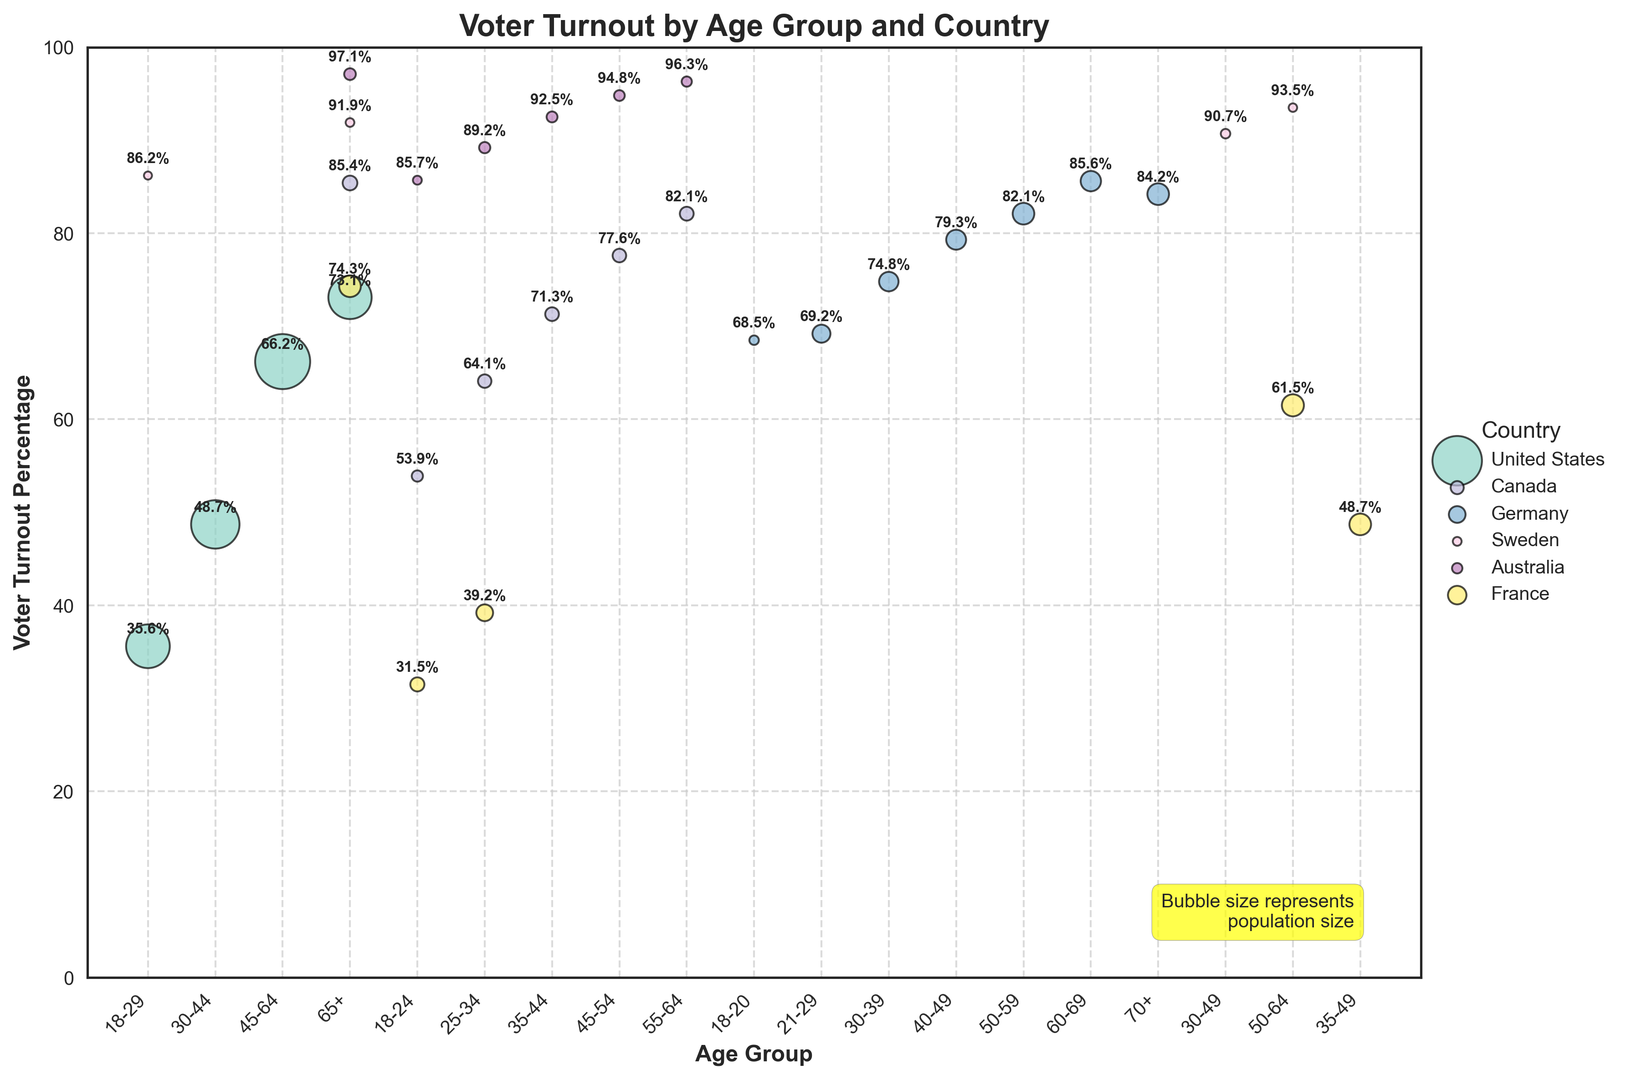What is the voter turnout percentage for the oldest age group in the United States? To find this, locate the bubble representing the United States in the age group "65+" and read off its associated percentage.
Answer: 73.1% Which country has the highest voter turnout percentage among the youngest age group? Compare the voter turnout percentages for the youngest age group across all countries, which are: United States (35.6%), Canada (53.9%), Germany (68.5%), Sweden (86.2%), Australia (85.7%), France (31.5%). The highest value is for Sweden.
Answer: Sweden Which country has the most significant difference in voter turnout percentage between the youngest and the oldest age groups? Calculate the difference between the turnout percentages for the youngest and oldest groups in each country: 
United States: 73.1 - 35.6 = 37.5, 
Canada: 85.4 - 53.9 = 31.5, 
Germany: 84.2 - 68.5 = 15.7,
Sweden: 91.9 - 86.2 = 5.7,
Australia: 97.1 - 85.7 = 11.4,
France: 74.3 - 31.5 = 42.8.
France has the most significant difference.
Answer: France Which age group shows the smallest bubble size across all countries, and what does it represent? Compare the size of the bubbles across different age groups. The smallest bubble size will be the smallest value of "Population_Size" in the dataset. The smallest size is for Sweden in the 18-29 age group, representing 1,800,000.
Answer: Sweden 18-29 Is the voter turnout percentage in the 50-64 age group higher in Canada or Germany? Compare the turnout percentages for the 50-64 age group: 
Canada: 82.1, 
Germany: 82.1.
Both are the same.
Answer: Same, 82.1 What is the average voter turnout percentage for the 18-24 age group across all countries? Add the voter turnout percentages for the 18-24 age group and divide by the number of countries: 
(35.6 + 53.9 + 68.5 + 86.2 + 85.7 + 31.5) / 6 = 61.9.
Answer: 61.9 Which country has the most dense clustering of bubbles (representing age groups) near the top of the chart? Examine the top region of the chart around the higher turnout percentages close to 100% and identify where the bubbles are closely packed together. Australia has closely packed bubbles in the 90s percentage range.
Answer: Australia How does the turnout of 18-29 year-olds in Canada compare to that in France? Compare the turnout percentages for the 18-29 age group in Canada (53.9) and France (31.5). Canada has a higher turnout.
Answer: Canada is higher Comparing France and Germany, which country has a higher overall voter turnout trend? Look at the voter turnout across different age groups in both countries. Most of Germany's age group bubbles are higher on the y-axis compared to France's age groups, indicating a higher overall turnout trend.
Answer: Germany 